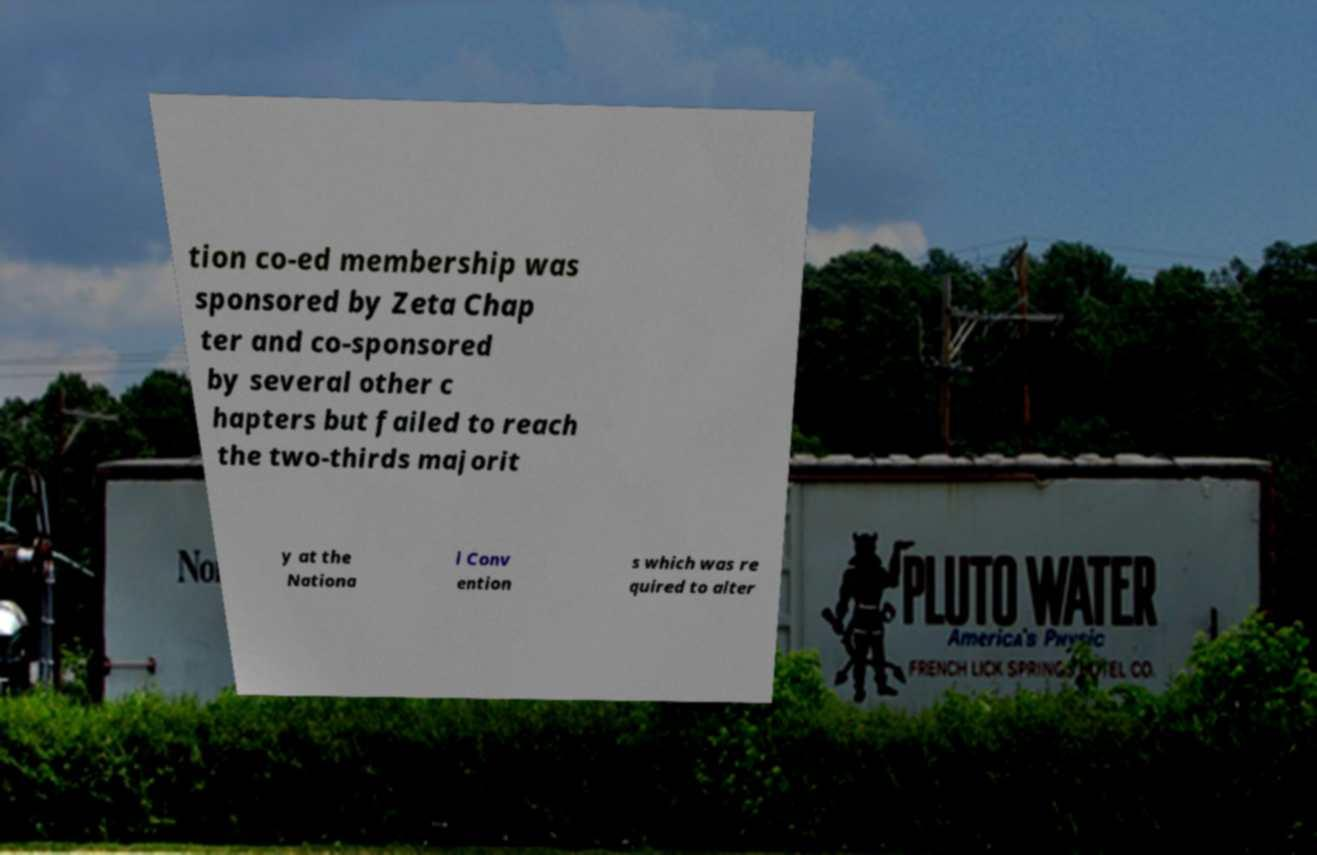Can you read and provide the text displayed in the image?This photo seems to have some interesting text. Can you extract and type it out for me? tion co-ed membership was sponsored by Zeta Chap ter and co-sponsored by several other c hapters but failed to reach the two-thirds majorit y at the Nationa l Conv ention s which was re quired to alter 